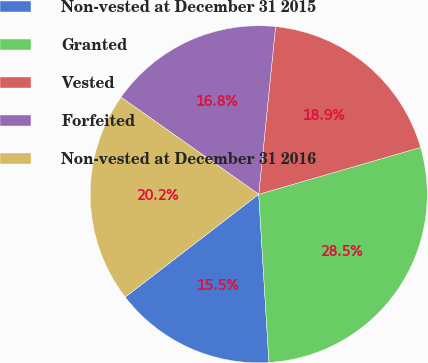<chart> <loc_0><loc_0><loc_500><loc_500><pie_chart><fcel>Non-vested at December 31 2015<fcel>Granted<fcel>Vested<fcel>Forfeited<fcel>Non-vested at December 31 2016<nl><fcel>15.52%<fcel>28.52%<fcel>18.92%<fcel>16.82%<fcel>20.22%<nl></chart> 